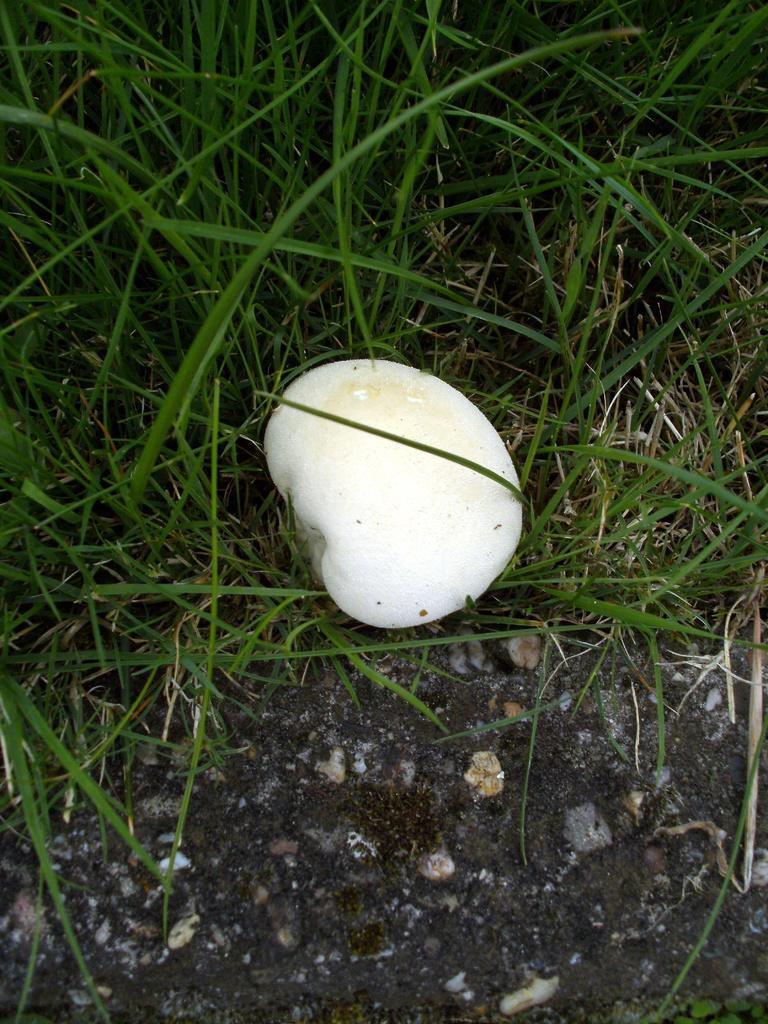Can you describe this image briefly? Here we can see a mushroom on the ground and this is grass. 